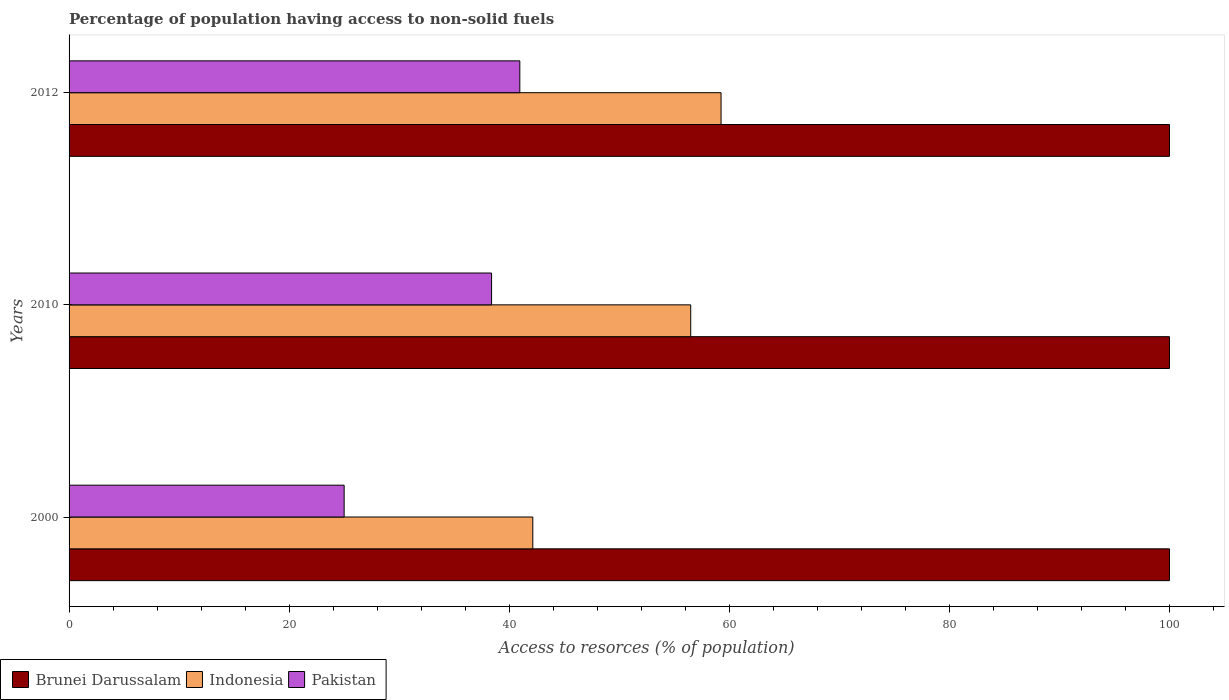How many groups of bars are there?
Keep it short and to the point. 3. Are the number of bars on each tick of the Y-axis equal?
Keep it short and to the point. Yes. How many bars are there on the 3rd tick from the top?
Make the answer very short. 3. How many bars are there on the 2nd tick from the bottom?
Your answer should be very brief. 3. What is the percentage of population having access to non-solid fuels in Brunei Darussalam in 2010?
Provide a succinct answer. 100. Across all years, what is the maximum percentage of population having access to non-solid fuels in Indonesia?
Your response must be concise. 59.25. Across all years, what is the minimum percentage of population having access to non-solid fuels in Brunei Darussalam?
Offer a terse response. 100. In which year was the percentage of population having access to non-solid fuels in Indonesia maximum?
Your answer should be very brief. 2012. In which year was the percentage of population having access to non-solid fuels in Pakistan minimum?
Provide a succinct answer. 2000. What is the total percentage of population having access to non-solid fuels in Indonesia in the graph?
Offer a very short reply. 157.88. What is the difference between the percentage of population having access to non-solid fuels in Indonesia in 2000 and that in 2010?
Offer a very short reply. -14.35. What is the difference between the percentage of population having access to non-solid fuels in Pakistan in 2010 and the percentage of population having access to non-solid fuels in Indonesia in 2000?
Keep it short and to the point. -3.75. What is the average percentage of population having access to non-solid fuels in Indonesia per year?
Your answer should be compact. 52.63. In the year 2010, what is the difference between the percentage of population having access to non-solid fuels in Pakistan and percentage of population having access to non-solid fuels in Brunei Darussalam?
Provide a short and direct response. -61.6. What is the ratio of the percentage of population having access to non-solid fuels in Indonesia in 2000 to that in 2012?
Provide a succinct answer. 0.71. Is the percentage of population having access to non-solid fuels in Pakistan in 2000 less than that in 2012?
Your answer should be compact. Yes. Is the difference between the percentage of population having access to non-solid fuels in Pakistan in 2000 and 2010 greater than the difference between the percentage of population having access to non-solid fuels in Brunei Darussalam in 2000 and 2010?
Your answer should be very brief. No. What is the difference between the highest and the second highest percentage of population having access to non-solid fuels in Pakistan?
Your answer should be compact. 2.57. What is the difference between the highest and the lowest percentage of population having access to non-solid fuels in Pakistan?
Give a very brief answer. 15.97. How many bars are there?
Provide a short and direct response. 9. How many years are there in the graph?
Give a very brief answer. 3. What is the difference between two consecutive major ticks on the X-axis?
Make the answer very short. 20. Are the values on the major ticks of X-axis written in scientific E-notation?
Offer a very short reply. No. What is the title of the graph?
Ensure brevity in your answer.  Percentage of population having access to non-solid fuels. What is the label or title of the X-axis?
Give a very brief answer. Access to resorces (% of population). What is the Access to resorces (% of population) of Indonesia in 2000?
Make the answer very short. 42.14. What is the Access to resorces (% of population) in Pakistan in 2000?
Make the answer very short. 25. What is the Access to resorces (% of population) of Indonesia in 2010?
Offer a very short reply. 56.49. What is the Access to resorces (% of population) of Pakistan in 2010?
Provide a short and direct response. 38.4. What is the Access to resorces (% of population) in Indonesia in 2012?
Give a very brief answer. 59.25. What is the Access to resorces (% of population) in Pakistan in 2012?
Provide a short and direct response. 40.96. Across all years, what is the maximum Access to resorces (% of population) in Brunei Darussalam?
Keep it short and to the point. 100. Across all years, what is the maximum Access to resorces (% of population) in Indonesia?
Provide a succinct answer. 59.25. Across all years, what is the maximum Access to resorces (% of population) in Pakistan?
Keep it short and to the point. 40.96. Across all years, what is the minimum Access to resorces (% of population) of Indonesia?
Provide a succinct answer. 42.14. Across all years, what is the minimum Access to resorces (% of population) in Pakistan?
Provide a succinct answer. 25. What is the total Access to resorces (% of population) in Brunei Darussalam in the graph?
Offer a very short reply. 300. What is the total Access to resorces (% of population) of Indonesia in the graph?
Your response must be concise. 157.88. What is the total Access to resorces (% of population) of Pakistan in the graph?
Ensure brevity in your answer.  104.35. What is the difference between the Access to resorces (% of population) of Brunei Darussalam in 2000 and that in 2010?
Make the answer very short. 0. What is the difference between the Access to resorces (% of population) in Indonesia in 2000 and that in 2010?
Your answer should be very brief. -14.35. What is the difference between the Access to resorces (% of population) in Pakistan in 2000 and that in 2010?
Make the answer very short. -13.4. What is the difference between the Access to resorces (% of population) of Brunei Darussalam in 2000 and that in 2012?
Give a very brief answer. 0. What is the difference between the Access to resorces (% of population) of Indonesia in 2000 and that in 2012?
Your answer should be very brief. -17.11. What is the difference between the Access to resorces (% of population) in Pakistan in 2000 and that in 2012?
Provide a short and direct response. -15.97. What is the difference between the Access to resorces (% of population) of Brunei Darussalam in 2010 and that in 2012?
Your answer should be compact. 0. What is the difference between the Access to resorces (% of population) of Indonesia in 2010 and that in 2012?
Your response must be concise. -2.76. What is the difference between the Access to resorces (% of population) of Pakistan in 2010 and that in 2012?
Your answer should be compact. -2.57. What is the difference between the Access to resorces (% of population) of Brunei Darussalam in 2000 and the Access to resorces (% of population) of Indonesia in 2010?
Give a very brief answer. 43.51. What is the difference between the Access to resorces (% of population) of Brunei Darussalam in 2000 and the Access to resorces (% of population) of Pakistan in 2010?
Give a very brief answer. 61.6. What is the difference between the Access to resorces (% of population) in Indonesia in 2000 and the Access to resorces (% of population) in Pakistan in 2010?
Provide a short and direct response. 3.75. What is the difference between the Access to resorces (% of population) in Brunei Darussalam in 2000 and the Access to resorces (% of population) in Indonesia in 2012?
Keep it short and to the point. 40.75. What is the difference between the Access to resorces (% of population) in Brunei Darussalam in 2000 and the Access to resorces (% of population) in Pakistan in 2012?
Offer a terse response. 59.04. What is the difference between the Access to resorces (% of population) in Indonesia in 2000 and the Access to resorces (% of population) in Pakistan in 2012?
Give a very brief answer. 1.18. What is the difference between the Access to resorces (% of population) of Brunei Darussalam in 2010 and the Access to resorces (% of population) of Indonesia in 2012?
Offer a very short reply. 40.75. What is the difference between the Access to resorces (% of population) in Brunei Darussalam in 2010 and the Access to resorces (% of population) in Pakistan in 2012?
Give a very brief answer. 59.04. What is the difference between the Access to resorces (% of population) in Indonesia in 2010 and the Access to resorces (% of population) in Pakistan in 2012?
Offer a terse response. 15.53. What is the average Access to resorces (% of population) of Brunei Darussalam per year?
Make the answer very short. 100. What is the average Access to resorces (% of population) in Indonesia per year?
Your answer should be compact. 52.63. What is the average Access to resorces (% of population) in Pakistan per year?
Offer a terse response. 34.78. In the year 2000, what is the difference between the Access to resorces (% of population) in Brunei Darussalam and Access to resorces (% of population) in Indonesia?
Keep it short and to the point. 57.86. In the year 2000, what is the difference between the Access to resorces (% of population) in Brunei Darussalam and Access to resorces (% of population) in Pakistan?
Keep it short and to the point. 75. In the year 2000, what is the difference between the Access to resorces (% of population) of Indonesia and Access to resorces (% of population) of Pakistan?
Your answer should be compact. 17.15. In the year 2010, what is the difference between the Access to resorces (% of population) of Brunei Darussalam and Access to resorces (% of population) of Indonesia?
Your answer should be compact. 43.51. In the year 2010, what is the difference between the Access to resorces (% of population) in Brunei Darussalam and Access to resorces (% of population) in Pakistan?
Your response must be concise. 61.6. In the year 2010, what is the difference between the Access to resorces (% of population) of Indonesia and Access to resorces (% of population) of Pakistan?
Your answer should be compact. 18.1. In the year 2012, what is the difference between the Access to resorces (% of population) in Brunei Darussalam and Access to resorces (% of population) in Indonesia?
Provide a short and direct response. 40.75. In the year 2012, what is the difference between the Access to resorces (% of population) in Brunei Darussalam and Access to resorces (% of population) in Pakistan?
Your response must be concise. 59.04. In the year 2012, what is the difference between the Access to resorces (% of population) of Indonesia and Access to resorces (% of population) of Pakistan?
Offer a terse response. 18.29. What is the ratio of the Access to resorces (% of population) in Indonesia in 2000 to that in 2010?
Your answer should be compact. 0.75. What is the ratio of the Access to resorces (% of population) in Pakistan in 2000 to that in 2010?
Your response must be concise. 0.65. What is the ratio of the Access to resorces (% of population) of Brunei Darussalam in 2000 to that in 2012?
Give a very brief answer. 1. What is the ratio of the Access to resorces (% of population) of Indonesia in 2000 to that in 2012?
Provide a succinct answer. 0.71. What is the ratio of the Access to resorces (% of population) of Pakistan in 2000 to that in 2012?
Your response must be concise. 0.61. What is the ratio of the Access to resorces (% of population) in Brunei Darussalam in 2010 to that in 2012?
Offer a terse response. 1. What is the ratio of the Access to resorces (% of population) in Indonesia in 2010 to that in 2012?
Offer a very short reply. 0.95. What is the ratio of the Access to resorces (% of population) in Pakistan in 2010 to that in 2012?
Keep it short and to the point. 0.94. What is the difference between the highest and the second highest Access to resorces (% of population) of Indonesia?
Keep it short and to the point. 2.76. What is the difference between the highest and the second highest Access to resorces (% of population) of Pakistan?
Offer a very short reply. 2.57. What is the difference between the highest and the lowest Access to resorces (% of population) in Indonesia?
Ensure brevity in your answer.  17.11. What is the difference between the highest and the lowest Access to resorces (% of population) in Pakistan?
Keep it short and to the point. 15.97. 